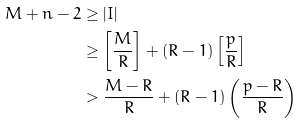Convert formula to latex. <formula><loc_0><loc_0><loc_500><loc_500>M + n - 2 & \geq | I | \\ & \geq \left [ \frac { M } { R } \right ] + ( R - 1 ) \left [ \frac { p } { R } \right ] \\ & > \frac { M - R } { R } + ( R - 1 ) \left ( \frac { p - R } { R } \right )</formula> 